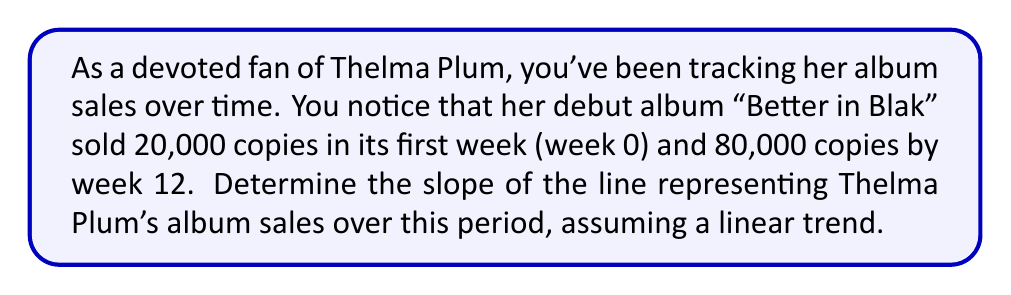Teach me how to tackle this problem. To find the slope of the line representing Thelma Plum's album sales over time, we'll use the slope formula:

$$ m = \frac{y_2 - y_1}{x_2 - x_1} $$

Where:
- $(x_1, y_1)$ is the first point (week 0, 20,000 copies)
- $(x_2, y_2)$ is the second point (week 12, 80,000 copies)

Let's plug in the values:

$$ m = \frac{80,000 - 20,000}{12 - 0} $$

$$ m = \frac{60,000}{12} $$

$$ m = 5,000 $$

This means that, on average, Thelma Plum's album "Better in Blak" sold 5,000 copies per week during this 12-week period.
Answer: $5,000$ copies per week 